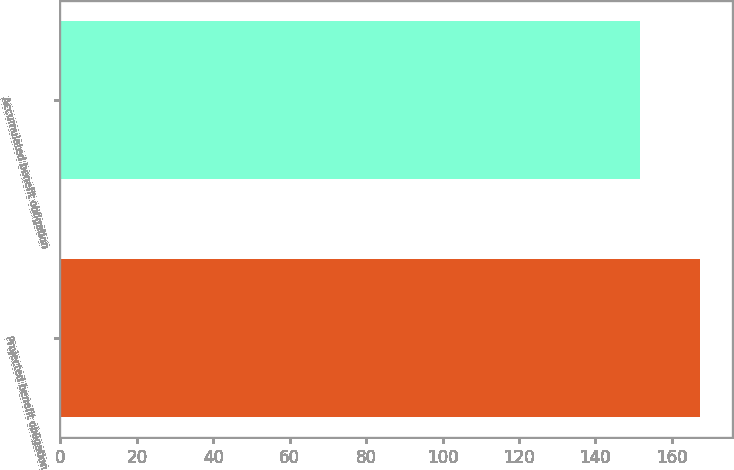<chart> <loc_0><loc_0><loc_500><loc_500><bar_chart><fcel>Projected benefit obligation<fcel>Accumulated benefit obligation<nl><fcel>167.3<fcel>151.6<nl></chart> 